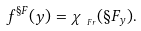<formula> <loc_0><loc_0><loc_500><loc_500>f ^ { \S F } ( y ) = \chi _ { _ { \ F r } } ( \S F _ { y } ) .</formula> 